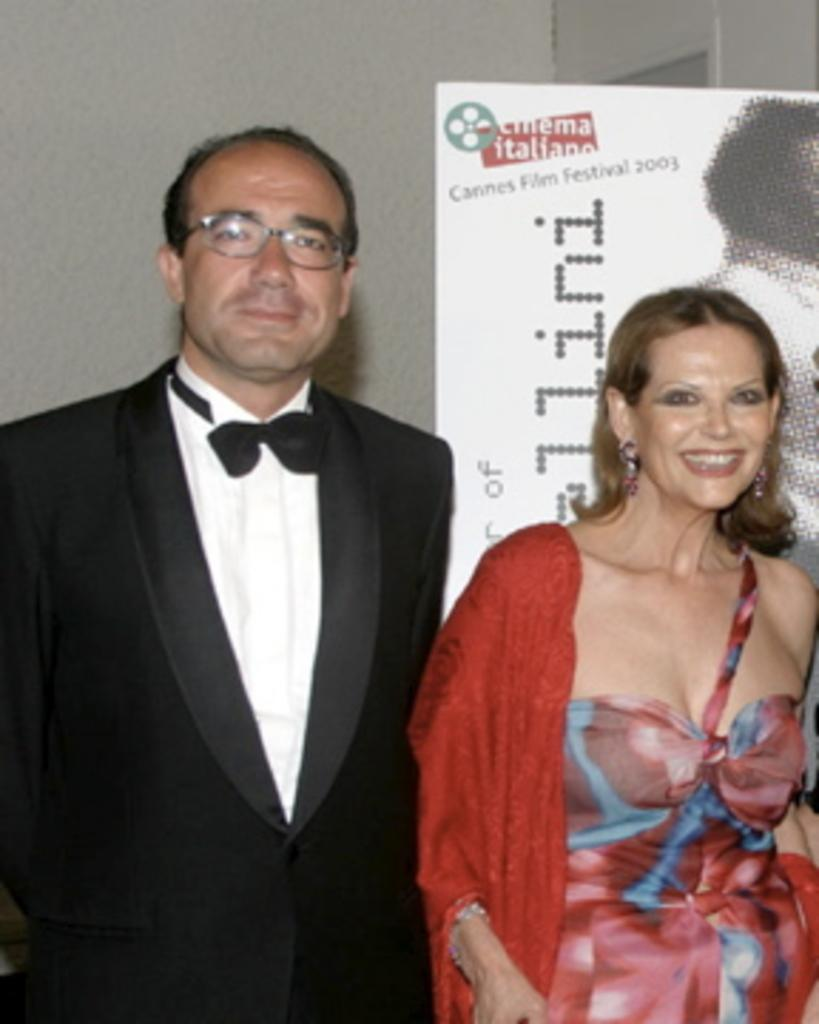How many people are present in the image? There is a man and a woman in the image, making a total of two people. What are the man and woman doing in the image? The man and woman are standing in the image. What can be seen on the advertisement board in the image? The advertisement board has text and a picture on it. What is visible in the background of the image? There is a wall in the background of the image. What is the chance of the pet winning the race in the image? There is no pet or race present in the image, so it is not possible to determine the chance of a pet winning a race. 